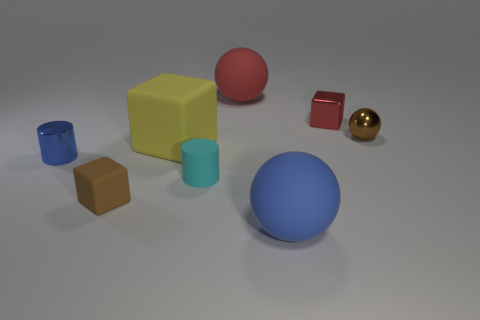Subtract all small brown spheres. How many spheres are left? 2 Add 1 blue matte balls. How many objects exist? 9 Subtract 1 blocks. How many blocks are left? 2 Subtract all cylinders. How many objects are left? 6 Subtract all cyan spheres. Subtract all yellow cubes. How many spheres are left? 3 Add 7 red shiny blocks. How many red shiny blocks exist? 8 Subtract 1 red blocks. How many objects are left? 7 Subtract all red matte spheres. Subtract all rubber cubes. How many objects are left? 5 Add 8 big blue balls. How many big blue balls are left? 9 